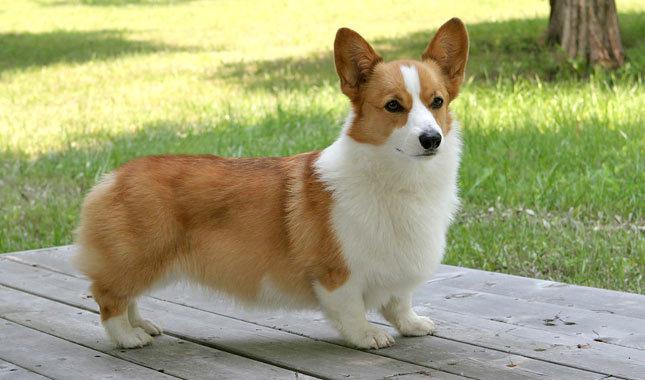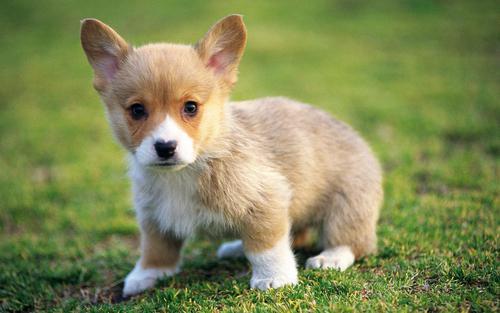The first image is the image on the left, the second image is the image on the right. Analyze the images presented: Is the assertion "The bodies of both dogs are facing the right." valid? Answer yes or no. No. 